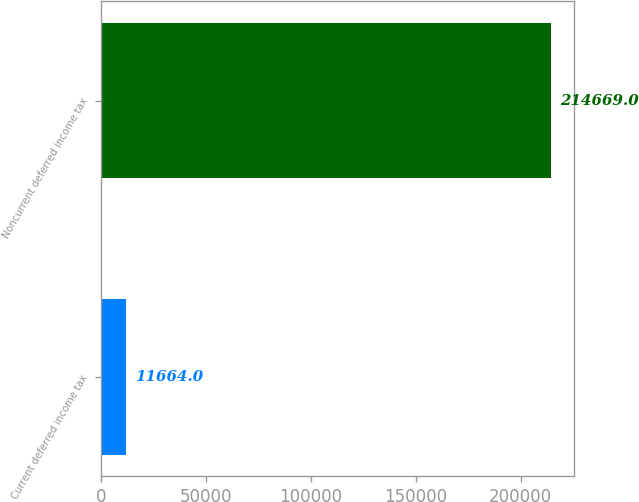Convert chart to OTSL. <chart><loc_0><loc_0><loc_500><loc_500><bar_chart><fcel>Current deferred income tax<fcel>Noncurrent deferred income tax<nl><fcel>11664<fcel>214669<nl></chart> 